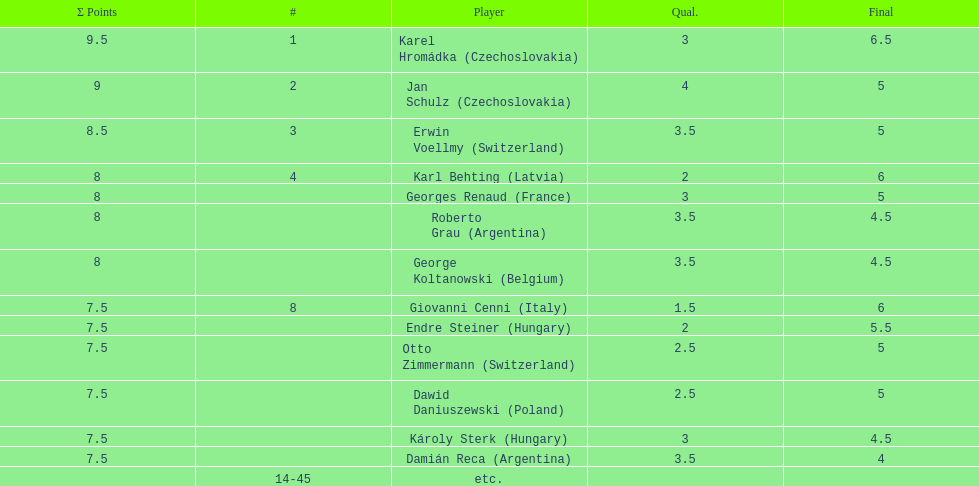How many countries had at least two players competing in the consolation cup? 4. 